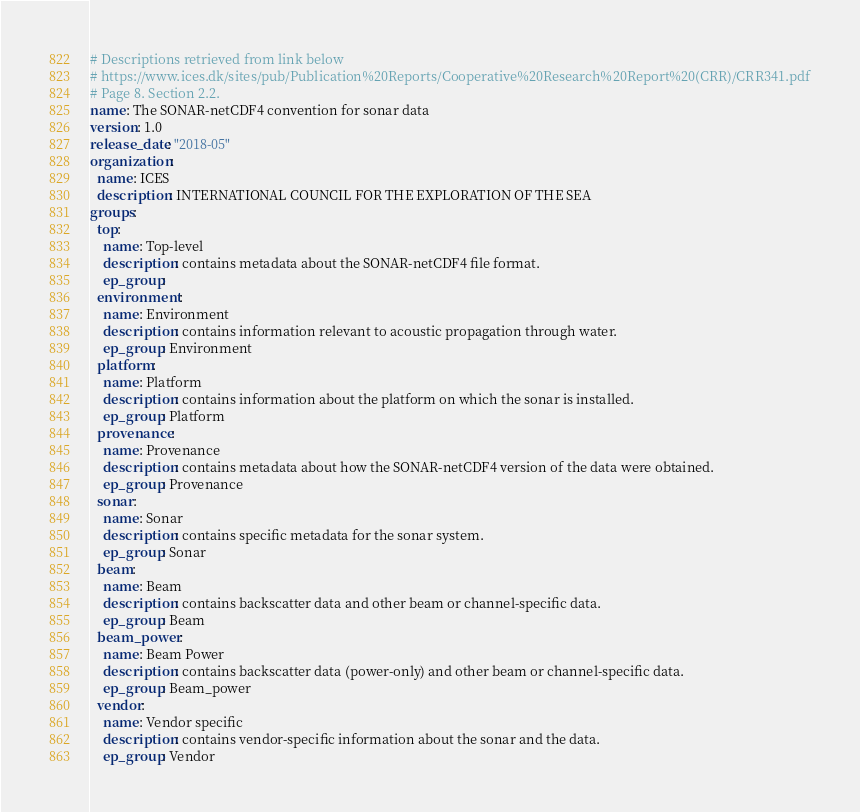<code> <loc_0><loc_0><loc_500><loc_500><_YAML_># Descriptions retrieved from link below
# https://www.ices.dk/sites/pub/Publication%20Reports/Cooperative%20Research%20Report%20(CRR)/CRR341.pdf
# Page 8. Section 2.2.
name: The SONAR-netCDF4 convention for sonar data
version: 1.0
release_date: "2018-05"
organization:
  name: ICES
  description: INTERNATIONAL COUNCIL FOR THE EXPLORATION OF THE SEA
groups:
  top:
    name: Top-level
    description: contains metadata about the SONAR-netCDF4 file format.
    ep_group:
  environment:
    name: Environment
    description: contains information relevant to acoustic propagation through water.
    ep_group: Environment
  platform:
    name: Platform
    description: contains information about the platform on which the sonar is installed.
    ep_group: Platform
  provenance:
    name: Provenance
    description: contains metadata about how the SONAR-netCDF4 version of the data were obtained.
    ep_group: Provenance
  sonar:
    name: Sonar
    description: contains specific metadata for the sonar system.
    ep_group: Sonar
  beam:
    name: Beam
    description: contains backscatter data and other beam or channel-specific data.
    ep_group: Beam
  beam_power:
    name: Beam Power
    description: contains backscatter data (power-only) and other beam or channel-specific data.
    ep_group: Beam_power
  vendor:
    name: Vendor specific
    description: contains vendor-specific information about the sonar and the data.
    ep_group: Vendor
</code> 